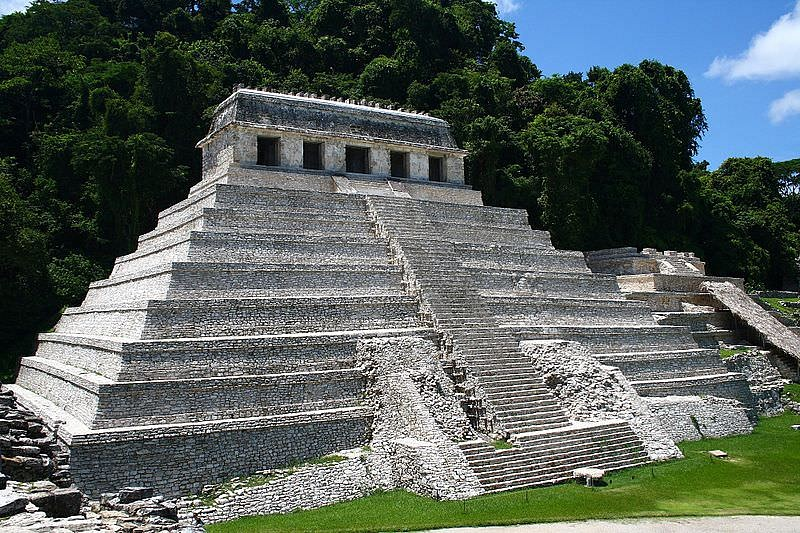Can you tell me more about the hieroglyphics found at the Temple of Inscriptions? Certainly! The hieroglyphics inside the Temple of Inscriptions are crucial to our understanding of Mayan civilization. They primarily record approximately 180 years of the city's history under rule of the Palenque dynasty. This includes detailed accounts of political events, religious ceremonies, and the lineage of rulers, particularly highlighting Pakal the Great, one of the most notable kings who is also buried within the temple. These inscriptions are an exceptional script resource, providing insight into Mayan language, ritual practices, and sociopolitical structure. 